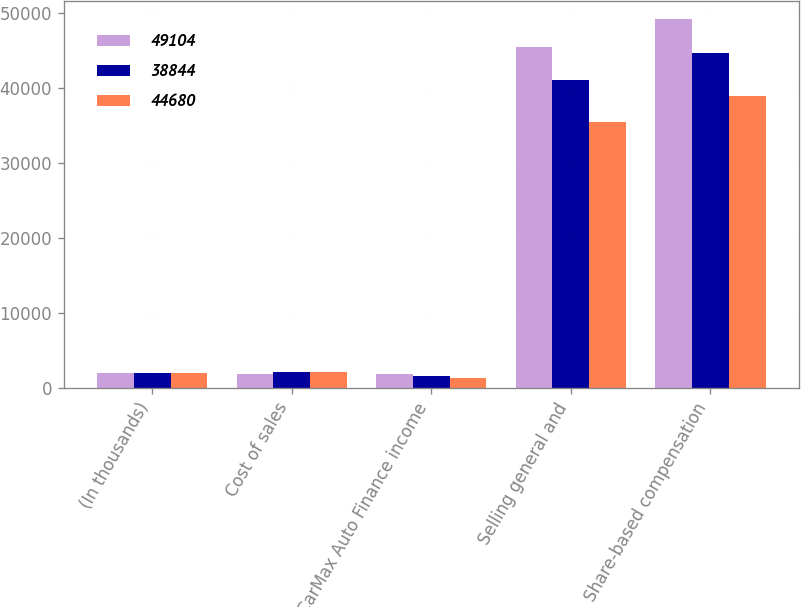Convert chart. <chart><loc_0><loc_0><loc_500><loc_500><stacked_bar_chart><ecel><fcel>(In thousands)<fcel>Cost of sales<fcel>CarMax Auto Finance income<fcel>Selling general and<fcel>Share-based compensation<nl><fcel>49104<fcel>2012<fcel>1845<fcel>1867<fcel>45392<fcel>49104<nl><fcel>38844<fcel>2011<fcel>2081<fcel>1603<fcel>40996<fcel>44680<nl><fcel>44680<fcel>2010<fcel>2103<fcel>1334<fcel>35407<fcel>38844<nl></chart> 